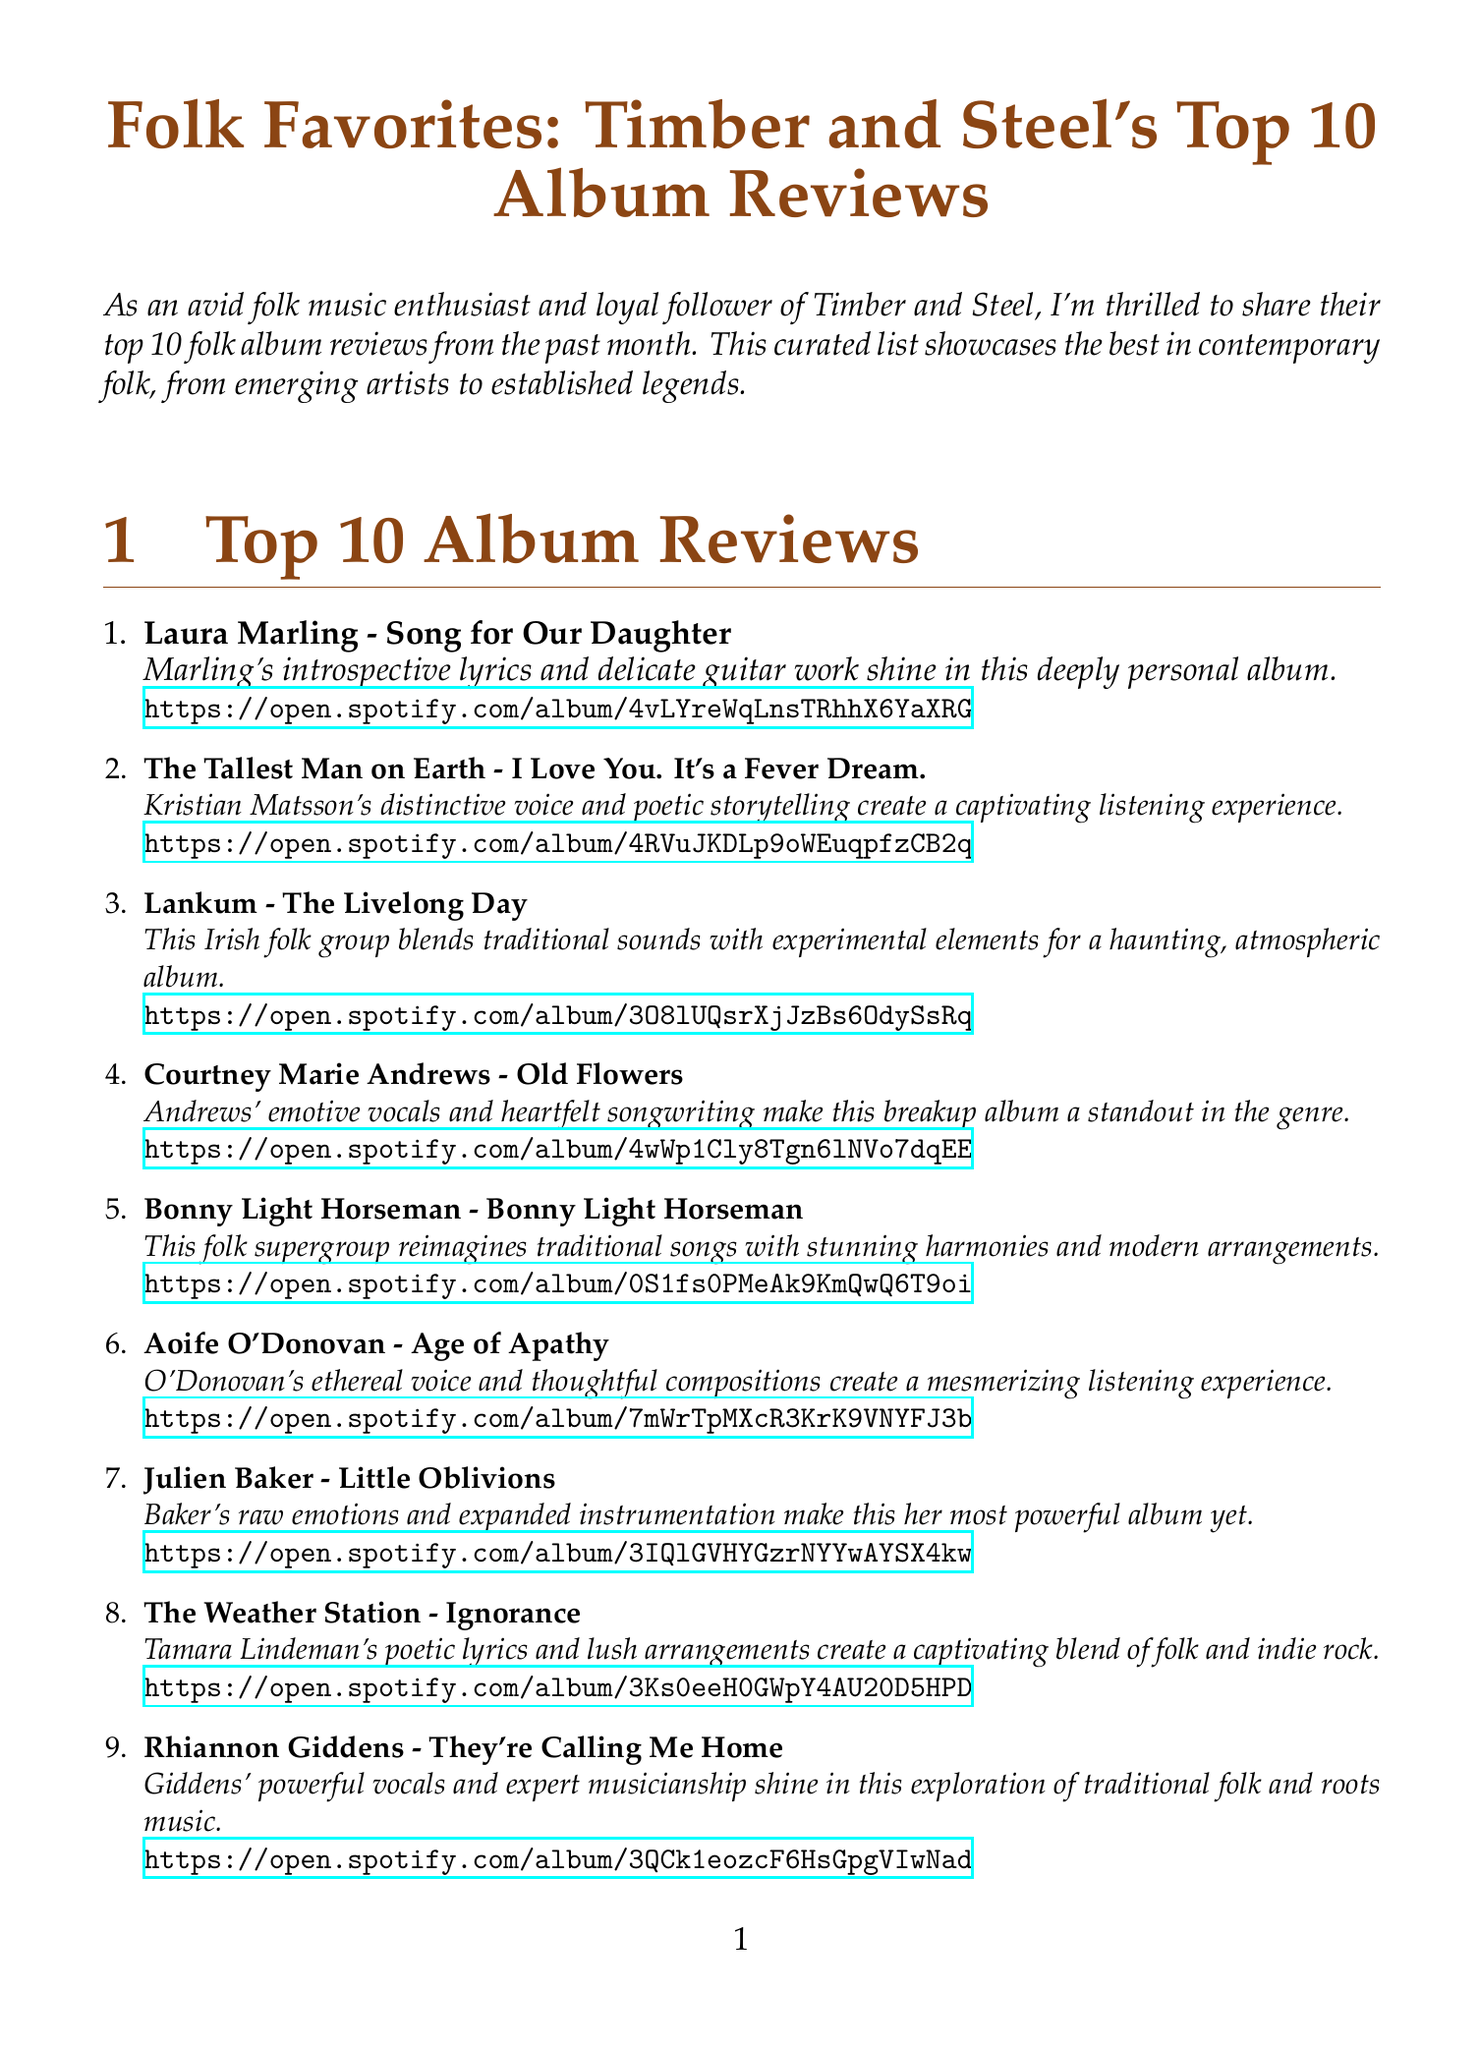What is the title of the newsletter? The title of the newsletter is presented at the beginning of the document.
Answer: Folk Favorites: Timber and Steel's Top 10 Album Reviews Who is the artist of the first-ranked album? The first-ranked album's artist is listed under the top 10 album reviews.
Answer: Laura Marling What is the review snippet for Fleet Foxes' album? The review snippet for Fleet Foxes is included in the list of album reviews.
Answer: The band's signature harmonies and intricate arrangements create a warm, inviting soundscape How many albums are listed in the top 10? The document explicitly states the number of albums in the top 10 album reviews section.
Answer: 10 What is the title of the playlist mentioned in the document? The title of the playlist is explicitly mentioned in the playlist information section.
Answer: Timber and Steel's Folk Favorites Which album ranked 6th? The rank 6 album title and artist are provided in the ranked list of album reviews.
Answer: Age of Apathy What genre do these albums represent? The newsletter context indicates the specific genre being highlighted through the reviews.
Answer: Folk Which artist is the last in the top 10 rankings? The document specifies the artist rankings in the album reviews section.
Answer: Fleet Foxes What is the link to the playlist? The link to the playlist is provided under the playlist information section in the document.
Answer: https://open.spotify.com/playlist/37i9dQZF1DWWEJlAGA9gs0 